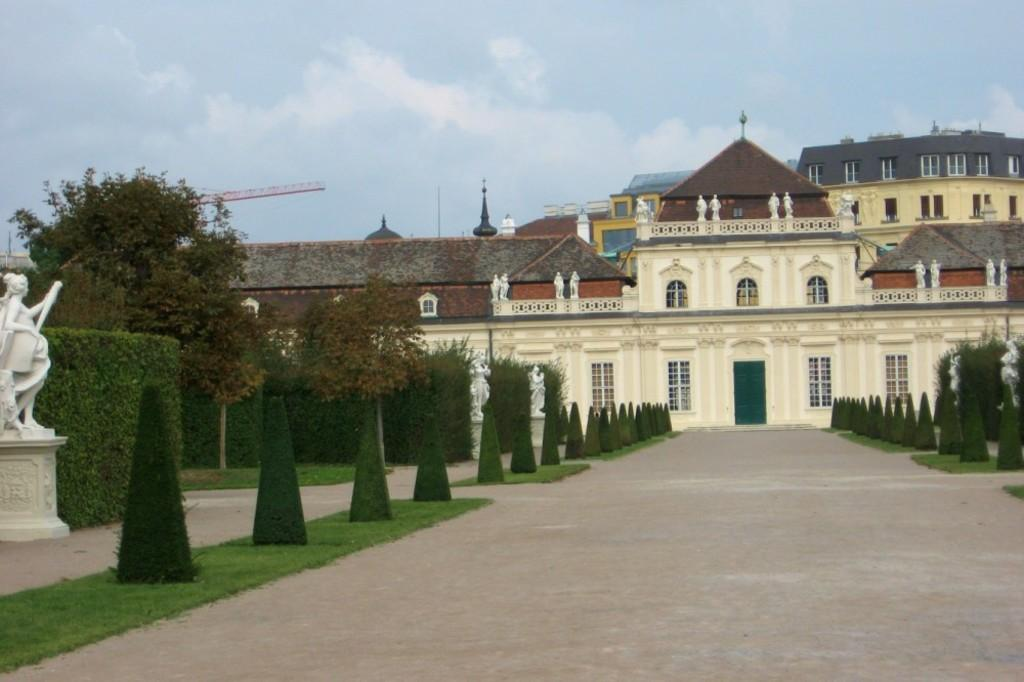What type of structures can be seen in the image? There are buildings in the image. What architectural features are visible on the buildings? There are windows and a door visible on the buildings. What type of vegetation is present in the image? There are trees in the image. What type of artwork is present in the image? There are white color statues in the image. What type of machinery is present in the image? There is a crane in the image. What is the color of the sky in the image? The sky is blue and white in color. Where is the hen located in the image? There is no hen present in the image. What type of animal is sitting on the monkey's shoulder in the image? There is no monkey or any other animal present in the image. What type of material is the canvas made of in the image? There is no canvas present in the image. 